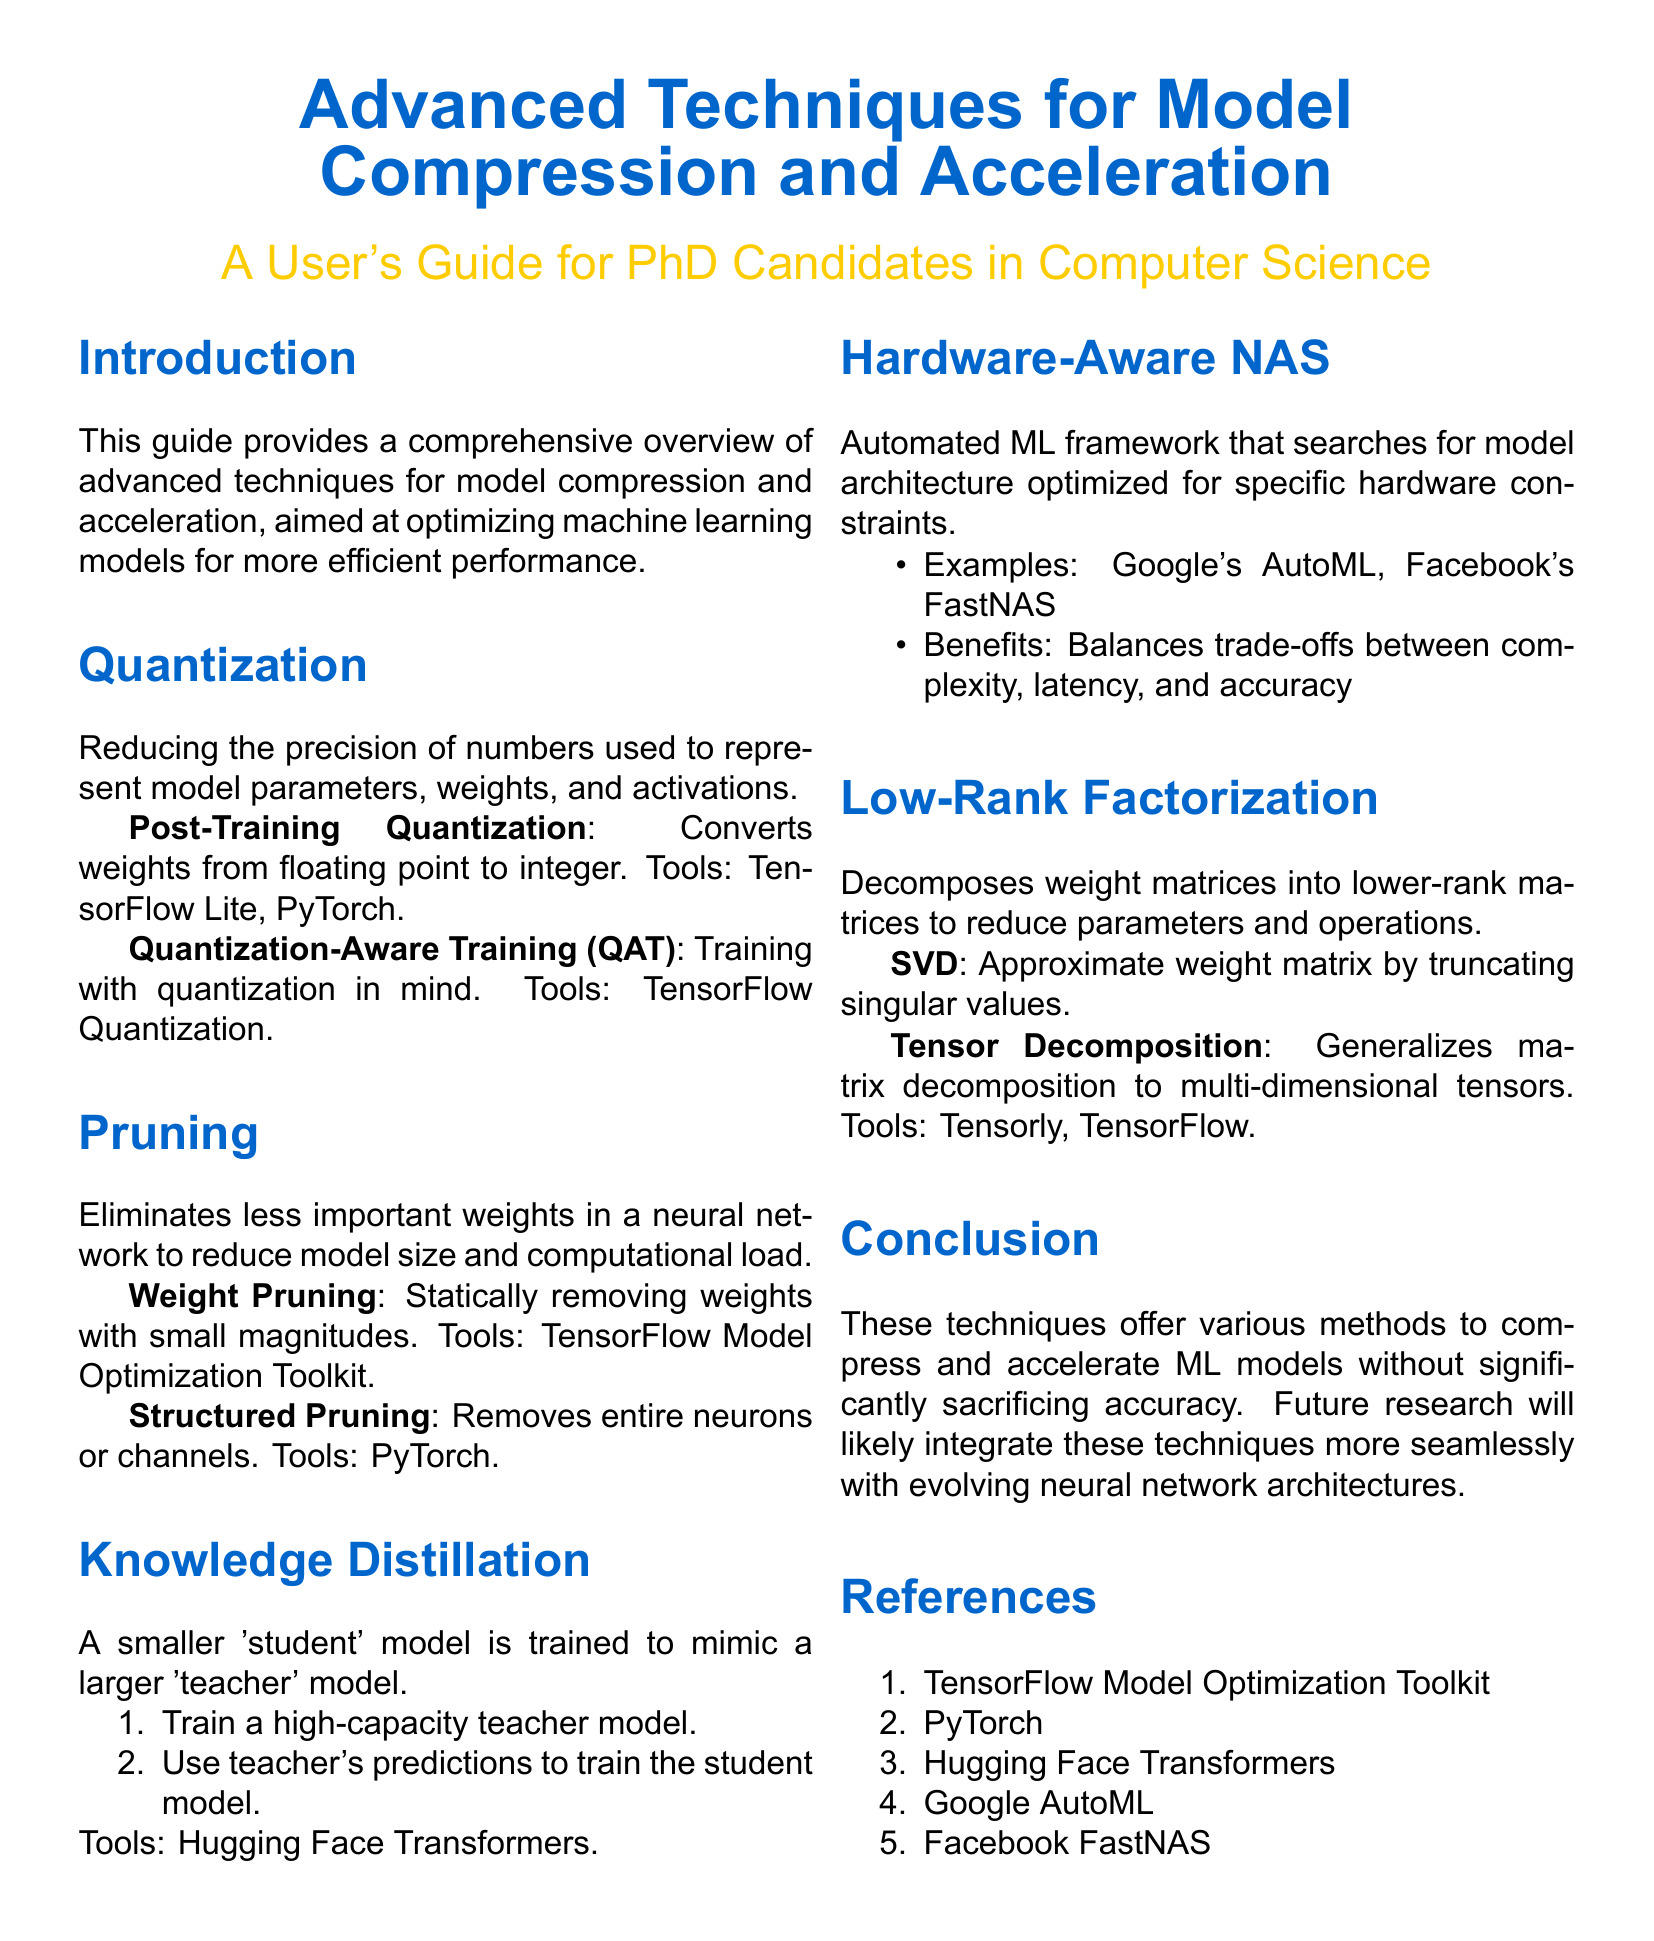What is the primary purpose of the user guide? The user guide aims to provide a comprehensive overview of advanced techniques for model compression and acceleration.
Answer: Model compression and acceleration What is one of the tools used for Post-Training Quantization? The document mentions TensorFlow Lite and PyTorch as tools for Post-Training Quantization.
Answer: TensorFlow Lite What does Structured Pruning remove from a neural network? The document states that Structured Pruning removes entire neurons or channels.
Answer: Entire neurons or channels Which technique involves training a smaller model to mimic a larger one? Knowledge Distillation entails training a smaller 'student' model to mimic a larger 'teacher' model.
Answer: Knowledge Distillation What is the function of Low-Rank Factorization in model optimization? Low-Rank Factorization decomposes weight matrices into lower-rank matrices to reduce parameters and operations.
Answer: Decomposes weight matrices What is the name of the automated ML framework mentioned for searching model architecture? The document lists Google's AutoML as an example of an automated ML framework for model architecture search.
Answer: Google's AutoML Which section discusses techniques to reduce model size? The section on Pruning discusses techniques to eliminate less important weights to reduce model size.
Answer: Pruning What type of training is Quantization-Aware Training (QAT)? Quantization-Aware Training (QAT) is described as training with quantization in mind.
Answer: Training with quantization in mind 